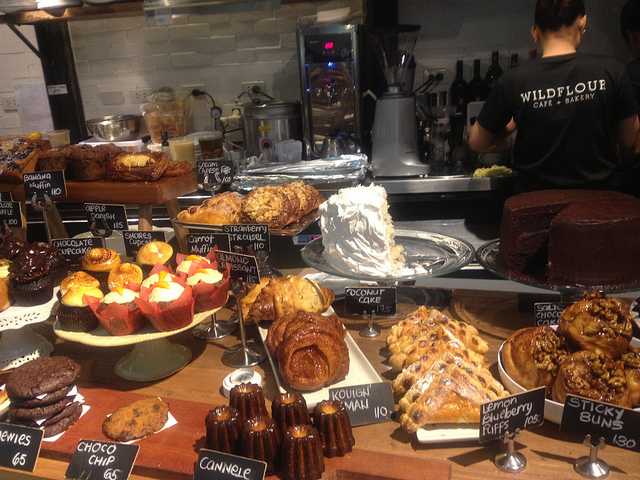Please transcribe the text in this image. WILDFLOUR COCONUT cake STRAWBERRY BAKER CAFE CHOCO 65 EWIES 65 chip CHOCO cannele 130 buns STICKY RUFFS Blueberry Lemon no MAN kouign 110 Upcake chocolate apple 110 